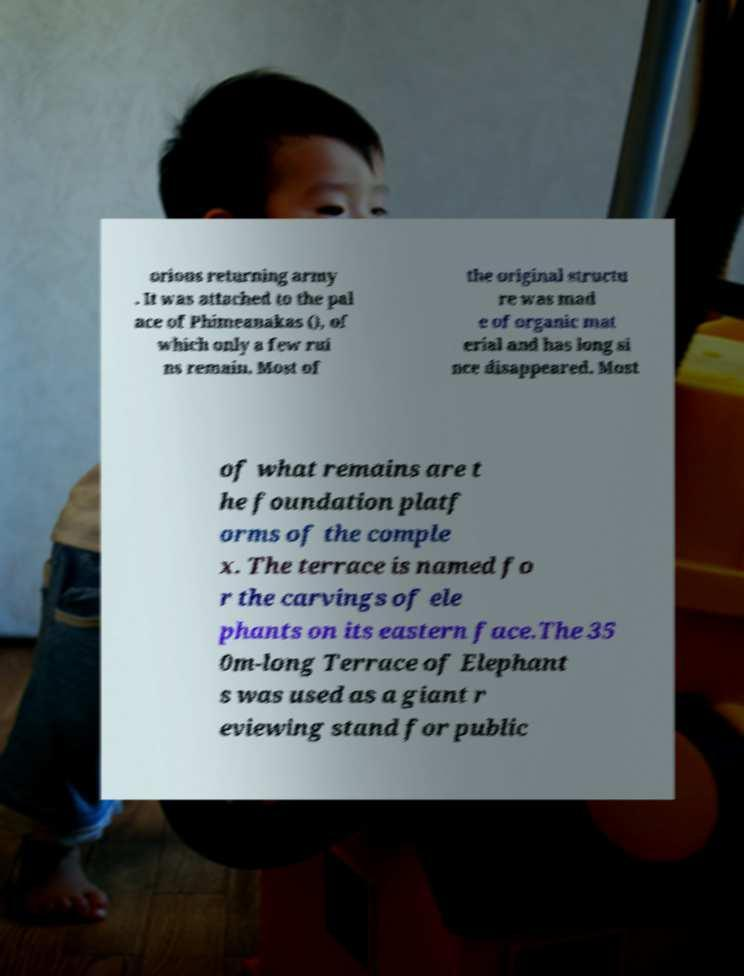Can you read and provide the text displayed in the image?This photo seems to have some interesting text. Can you extract and type it out for me? orious returning army . It was attached to the pal ace of Phimeanakas (), of which only a few rui ns remain. Most of the original structu re was mad e of organic mat erial and has long si nce disappeared. Most of what remains are t he foundation platf orms of the comple x. The terrace is named fo r the carvings of ele phants on its eastern face.The 35 0m-long Terrace of Elephant s was used as a giant r eviewing stand for public 